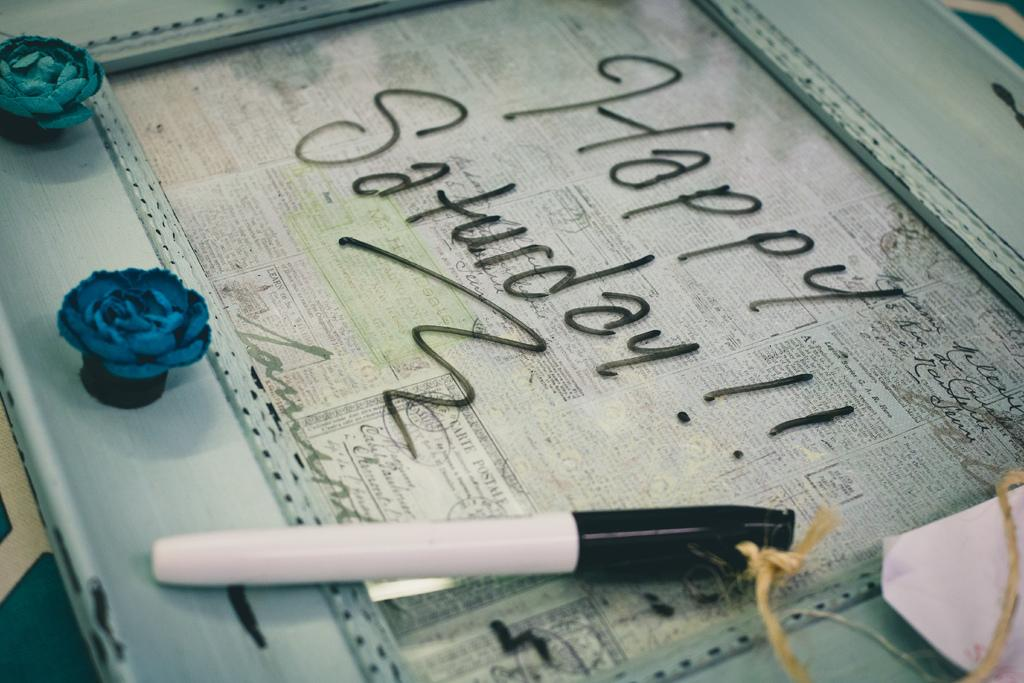What is located in the foreground of the image? There is a photo frame in the foreground of the image. What is attached to the photo frame? A marker and a rope are present on the photo frame. What is placed on the photo frame? There is a paper on the photo frame. What message is written on the photo frame? The text "HAPPY SATURDAY !!" is written on the photo frame. Where is the stove located in the image? There is no stove present in the image. What type of ring is visible on the photo frame? There is no ring visible on the photo frame; only a marker, rope, and paper are present. 